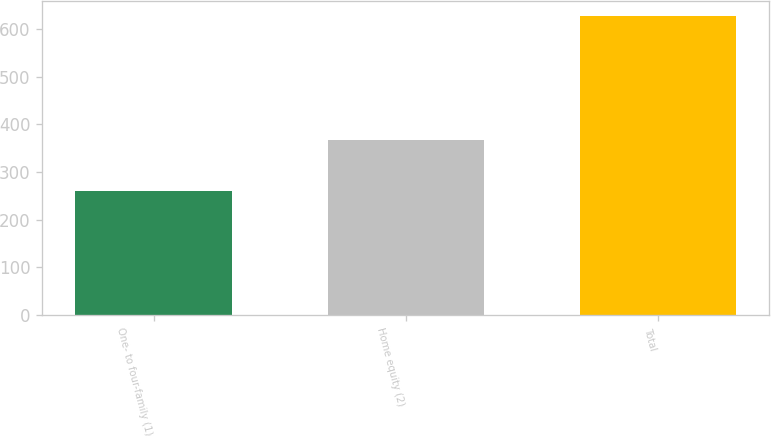Convert chart to OTSL. <chart><loc_0><loc_0><loc_500><loc_500><bar_chart><fcel>One- to four-family (1)<fcel>Home equity (2)<fcel>Total<nl><fcel>260<fcel>367<fcel>627<nl></chart> 